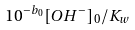<formula> <loc_0><loc_0><loc_500><loc_500>1 0 ^ { - b _ { 0 } } [ O H ^ { - } ] _ { 0 } / K _ { w }</formula> 